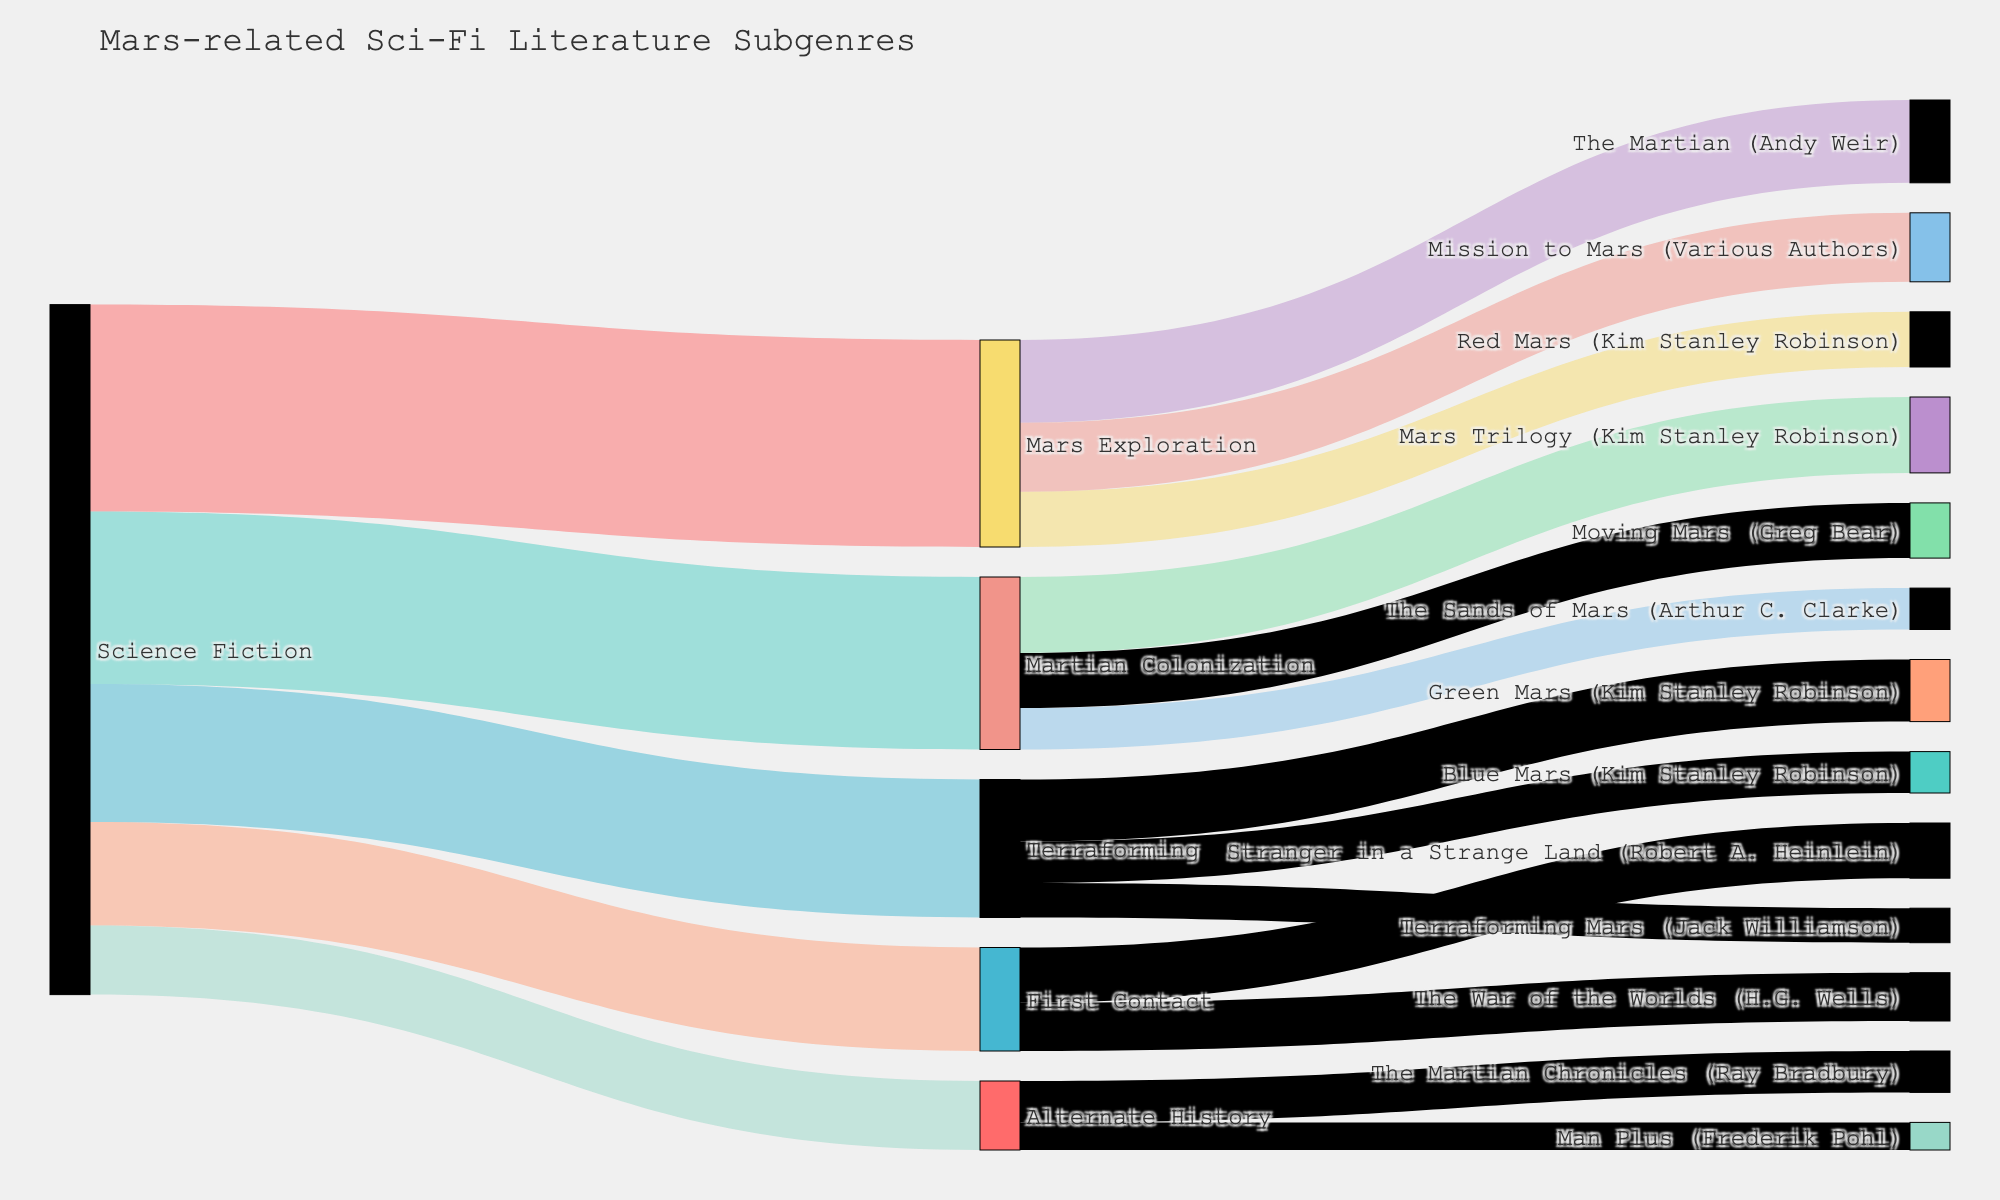What's the title of this figure? The title of the figure is always displayed prominently at the top. It is provided in the code as part of the layout configuration. Simply read the text at the top of the figure, which says "Mars-related Sci-Fi Literature Subgenres."
Answer: Mars-related Sci-Fi Literature Subgenres Which subgenre has the highest value connected to "Science Fiction"? First, identify the links that start from "Science Fiction" and their corresponding values. Compare these values: Mars Exploration (30), Martian Colonization (25), Terraforming (20), First Contact (15), and Alternate History (10). Mars Exploration has the highest value.
Answer: Mars Exploration How many works are listed under "Terraforming"? Look at the links that start from "Terraforming" and count them. The works linked to Terraforming are Terraforming Mars, Green Mars, and Blue Mars, making a total of 3.
Answer: 3 What is the combined value of "Martian Colonization" subgenre? Identify all the values connected to the "Martian Colonization" subgenre: The Sands of Mars (6), Mars Trilogy (11), and Moving Mars (8). Sum them up: 6 + 11 + 8 = 25.
Answer: 25 Which literary work under "First Contact" has the higher value? Identify the links from "First Contact" and compare their values: The War of the Worlds (7) and Stranger in a Strange Land (8). Stranger in a Strange Land has the higher value.
Answer: Stranger in a Strange Land What is the difference in value between "Red Mars" and "Green Mars"? Identify their respective values: Red Mars (8) and Green Mars (9). Calculate the difference: 9 - 8 = 1.
Answer: 1 How many subgenres are connected to the main category (Science Fiction)? Identify the distinct subgenres linked directly from "Science Fiction": Mars Exploration, Martian Colonization, Terraforming, First Contact, and Alternate History. There are 5 subgenres in total.
Answer: 5 Which subgenre has the least popular work, and what is that work's value? Identify the least value work under each subgenre: Red Mars (8), The Sands of Mars (6), Terraforming Mars (5), The War of the Worlds (7), and Man Plus (4). The work with the minimum value is Man Plus (4).
Answer: Alternate History; Value is 4 What is the combined value of all works authored by Kim Stanley Robinson? Identify all the works by Kim Stanley Robinson and their values: Red Mars (8), Green Mars (9), and Blue Mars (6) in Mars Exploration and Terraforming Mars Trilogy (11). Sum them up: 8 + 9 + 6 + 11 = 34.
Answer: 34 How does the number of works under "Mars Exploration" compare to "Martian Colonization"? Count the works under each subgenre: Mars Exploration has 3 works (Red Mars, The Martian, Mission to Mars) and Martian Colonization has 3 works (The Sands of Mars, Mars Trilogy, Moving Mars). Both have the same number of works.
Answer: Both have 3 works 